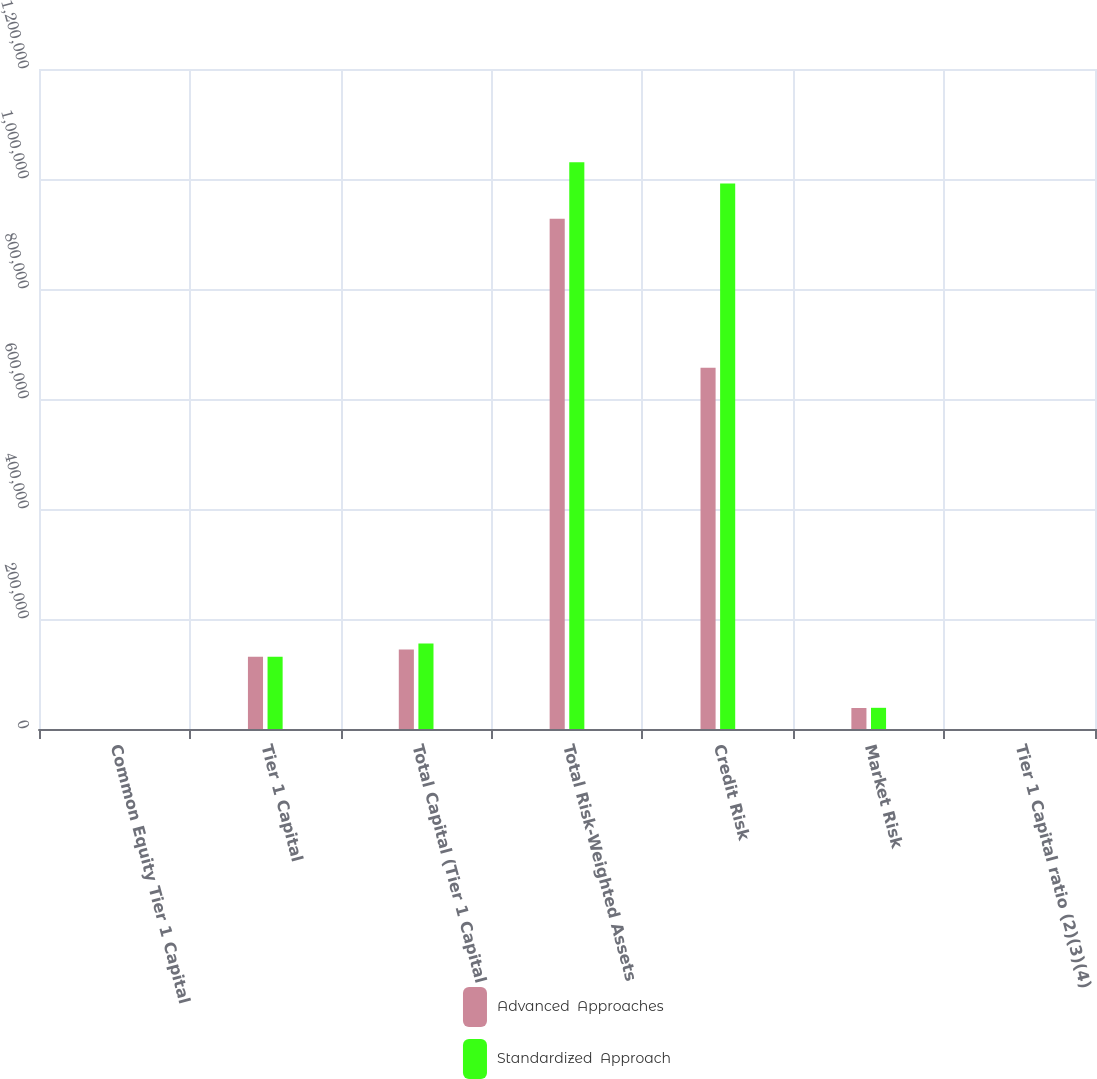Convert chart. <chart><loc_0><loc_0><loc_500><loc_500><stacked_bar_chart><ecel><fcel>Common Equity Tier 1 Capital<fcel>Tier 1 Capital<fcel>Total Capital (Tier 1 Capital<fcel>Total Risk-Weighted Assets<fcel>Credit Risk<fcel>Market Risk<fcel>Tier 1 Capital ratio (2)(3)(4)<nl><fcel>Advanced  Approaches<fcel>13.93<fcel>131341<fcel>144485<fcel>927931<fcel>656664<fcel>38144<fcel>14.15<nl><fcel>Standardized  Approach<fcel>12.54<fcel>131341<fcel>155280<fcel>1.03051e+06<fcel>991999<fcel>38515<fcel>12.75<nl></chart> 